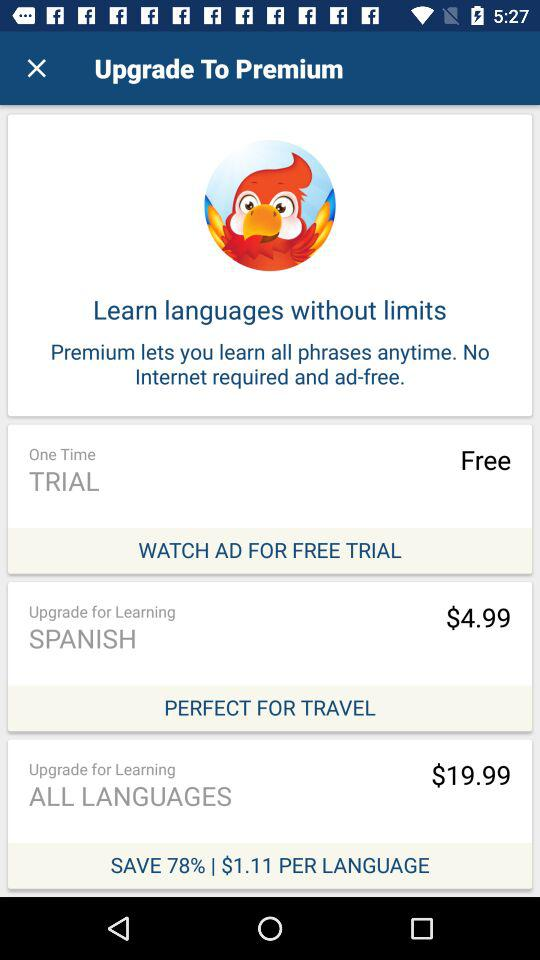How much is the upgrade to learn Korean?
When the provided information is insufficient, respond with <no answer>. <no answer> 